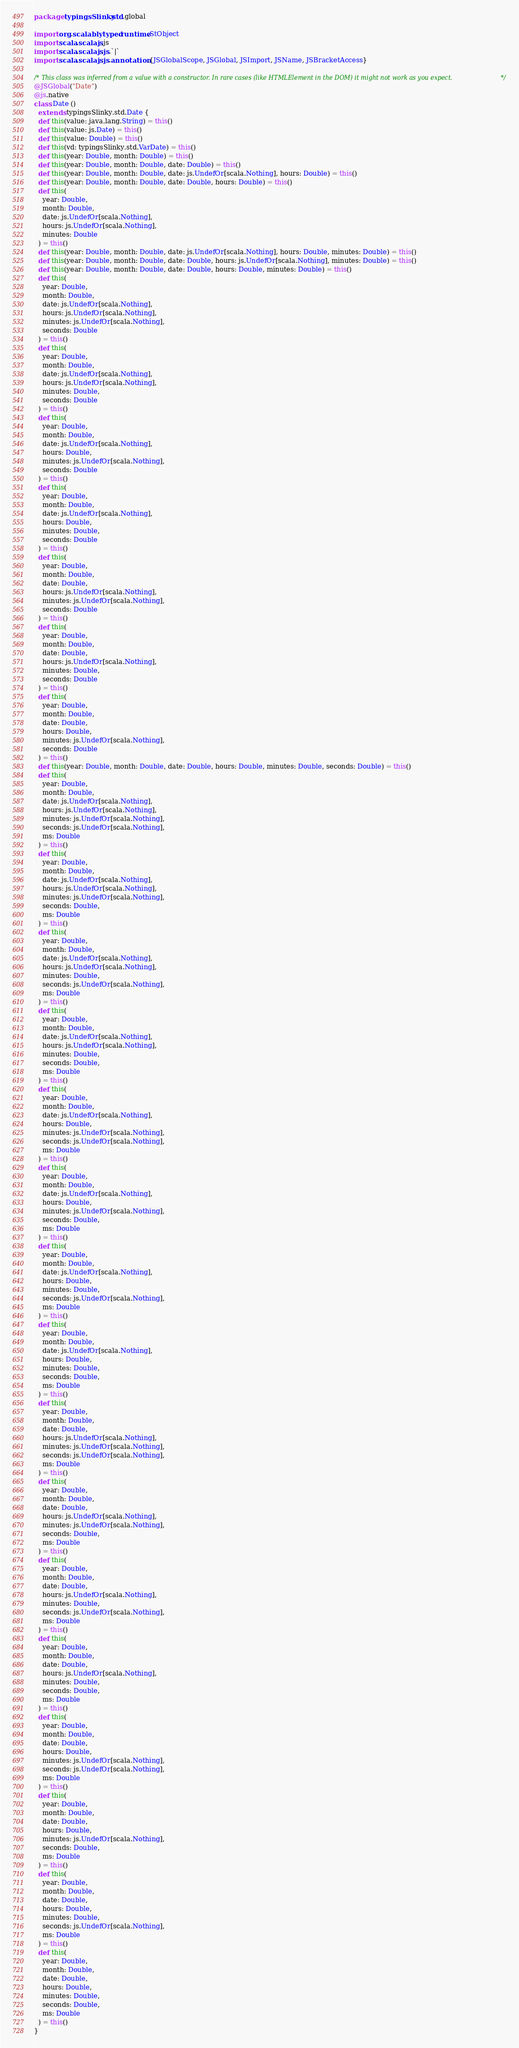<code> <loc_0><loc_0><loc_500><loc_500><_Scala_>package typingsSlinky.std.global

import org.scalablytyped.runtime.StObject
import scala.scalajs.js
import scala.scalajs.js.`|`
import scala.scalajs.js.annotation.{JSGlobalScope, JSGlobal, JSImport, JSName, JSBracketAccess}

/* This class was inferred from a value with a constructor. In rare cases (like HTMLElement in the DOM) it might not work as you expect. */
@JSGlobal("Date")
@js.native
class Date ()
  extends typingsSlinky.std.Date {
  def this(value: java.lang.String) = this()
  def this(value: js.Date) = this()
  def this(value: Double) = this()
  def this(vd: typingsSlinky.std.VarDate) = this()
  def this(year: Double, month: Double) = this()
  def this(year: Double, month: Double, date: Double) = this()
  def this(year: Double, month: Double, date: js.UndefOr[scala.Nothing], hours: Double) = this()
  def this(year: Double, month: Double, date: Double, hours: Double) = this()
  def this(
    year: Double,
    month: Double,
    date: js.UndefOr[scala.Nothing],
    hours: js.UndefOr[scala.Nothing],
    minutes: Double
  ) = this()
  def this(year: Double, month: Double, date: js.UndefOr[scala.Nothing], hours: Double, minutes: Double) = this()
  def this(year: Double, month: Double, date: Double, hours: js.UndefOr[scala.Nothing], minutes: Double) = this()
  def this(year: Double, month: Double, date: Double, hours: Double, minutes: Double) = this()
  def this(
    year: Double,
    month: Double,
    date: js.UndefOr[scala.Nothing],
    hours: js.UndefOr[scala.Nothing],
    minutes: js.UndefOr[scala.Nothing],
    seconds: Double
  ) = this()
  def this(
    year: Double,
    month: Double,
    date: js.UndefOr[scala.Nothing],
    hours: js.UndefOr[scala.Nothing],
    minutes: Double,
    seconds: Double
  ) = this()
  def this(
    year: Double,
    month: Double,
    date: js.UndefOr[scala.Nothing],
    hours: Double,
    minutes: js.UndefOr[scala.Nothing],
    seconds: Double
  ) = this()
  def this(
    year: Double,
    month: Double,
    date: js.UndefOr[scala.Nothing],
    hours: Double,
    minutes: Double,
    seconds: Double
  ) = this()
  def this(
    year: Double,
    month: Double,
    date: Double,
    hours: js.UndefOr[scala.Nothing],
    minutes: js.UndefOr[scala.Nothing],
    seconds: Double
  ) = this()
  def this(
    year: Double,
    month: Double,
    date: Double,
    hours: js.UndefOr[scala.Nothing],
    minutes: Double,
    seconds: Double
  ) = this()
  def this(
    year: Double,
    month: Double,
    date: Double,
    hours: Double,
    minutes: js.UndefOr[scala.Nothing],
    seconds: Double
  ) = this()
  def this(year: Double, month: Double, date: Double, hours: Double, minutes: Double, seconds: Double) = this()
  def this(
    year: Double,
    month: Double,
    date: js.UndefOr[scala.Nothing],
    hours: js.UndefOr[scala.Nothing],
    minutes: js.UndefOr[scala.Nothing],
    seconds: js.UndefOr[scala.Nothing],
    ms: Double
  ) = this()
  def this(
    year: Double,
    month: Double,
    date: js.UndefOr[scala.Nothing],
    hours: js.UndefOr[scala.Nothing],
    minutes: js.UndefOr[scala.Nothing],
    seconds: Double,
    ms: Double
  ) = this()
  def this(
    year: Double,
    month: Double,
    date: js.UndefOr[scala.Nothing],
    hours: js.UndefOr[scala.Nothing],
    minutes: Double,
    seconds: js.UndefOr[scala.Nothing],
    ms: Double
  ) = this()
  def this(
    year: Double,
    month: Double,
    date: js.UndefOr[scala.Nothing],
    hours: js.UndefOr[scala.Nothing],
    minutes: Double,
    seconds: Double,
    ms: Double
  ) = this()
  def this(
    year: Double,
    month: Double,
    date: js.UndefOr[scala.Nothing],
    hours: Double,
    minutes: js.UndefOr[scala.Nothing],
    seconds: js.UndefOr[scala.Nothing],
    ms: Double
  ) = this()
  def this(
    year: Double,
    month: Double,
    date: js.UndefOr[scala.Nothing],
    hours: Double,
    minutes: js.UndefOr[scala.Nothing],
    seconds: Double,
    ms: Double
  ) = this()
  def this(
    year: Double,
    month: Double,
    date: js.UndefOr[scala.Nothing],
    hours: Double,
    minutes: Double,
    seconds: js.UndefOr[scala.Nothing],
    ms: Double
  ) = this()
  def this(
    year: Double,
    month: Double,
    date: js.UndefOr[scala.Nothing],
    hours: Double,
    minutes: Double,
    seconds: Double,
    ms: Double
  ) = this()
  def this(
    year: Double,
    month: Double,
    date: Double,
    hours: js.UndefOr[scala.Nothing],
    minutes: js.UndefOr[scala.Nothing],
    seconds: js.UndefOr[scala.Nothing],
    ms: Double
  ) = this()
  def this(
    year: Double,
    month: Double,
    date: Double,
    hours: js.UndefOr[scala.Nothing],
    minutes: js.UndefOr[scala.Nothing],
    seconds: Double,
    ms: Double
  ) = this()
  def this(
    year: Double,
    month: Double,
    date: Double,
    hours: js.UndefOr[scala.Nothing],
    minutes: Double,
    seconds: js.UndefOr[scala.Nothing],
    ms: Double
  ) = this()
  def this(
    year: Double,
    month: Double,
    date: Double,
    hours: js.UndefOr[scala.Nothing],
    minutes: Double,
    seconds: Double,
    ms: Double
  ) = this()
  def this(
    year: Double,
    month: Double,
    date: Double,
    hours: Double,
    minutes: js.UndefOr[scala.Nothing],
    seconds: js.UndefOr[scala.Nothing],
    ms: Double
  ) = this()
  def this(
    year: Double,
    month: Double,
    date: Double,
    hours: Double,
    minutes: js.UndefOr[scala.Nothing],
    seconds: Double,
    ms: Double
  ) = this()
  def this(
    year: Double,
    month: Double,
    date: Double,
    hours: Double,
    minutes: Double,
    seconds: js.UndefOr[scala.Nothing],
    ms: Double
  ) = this()
  def this(
    year: Double,
    month: Double,
    date: Double,
    hours: Double,
    minutes: Double,
    seconds: Double,
    ms: Double
  ) = this()
}
</code> 